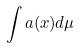<formula> <loc_0><loc_0><loc_500><loc_500>\int a ( x ) d \mu</formula> 